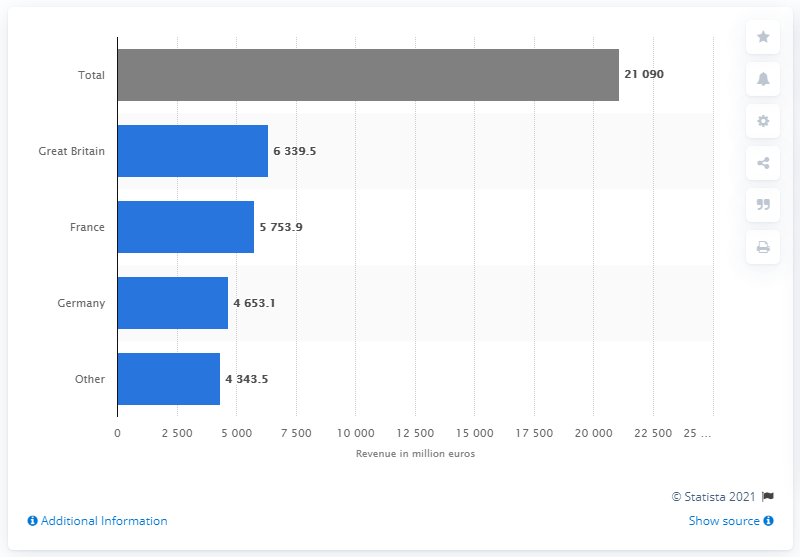Identify some key points in this picture. In 2018, the revenue of McKesson Europe in France was 5,753.9 million euros. 